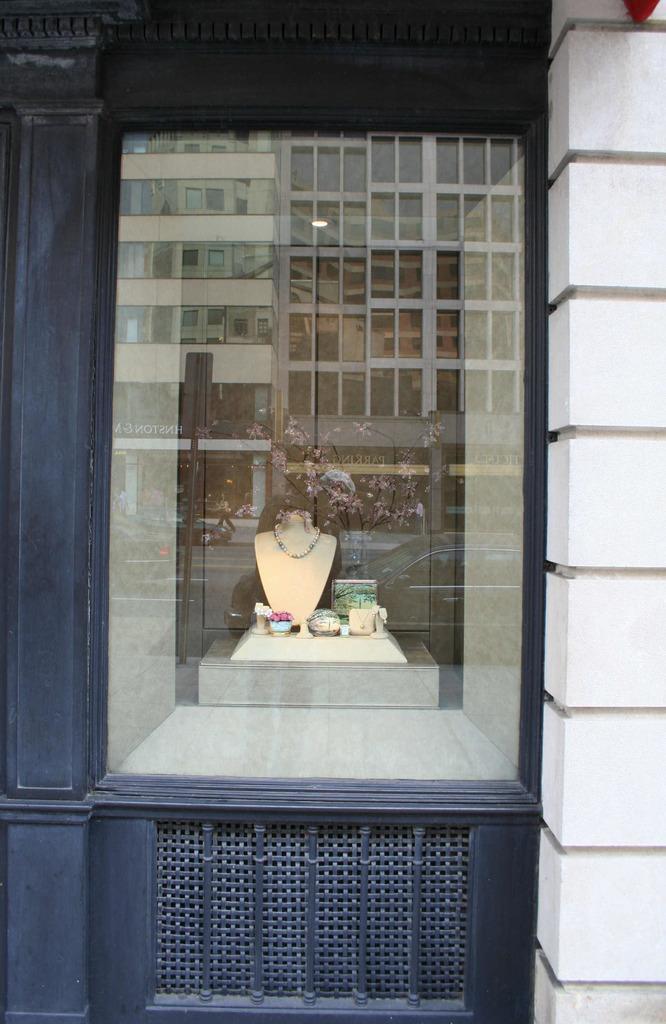Describe this image in one or two sentences. In the picture I can see the glass window through which I can see a chain and few more objects are showcased here. Here we can see the reflection of buildings, vehicles moving on the road, people walking on the sidewalk and boards on the glass window. 